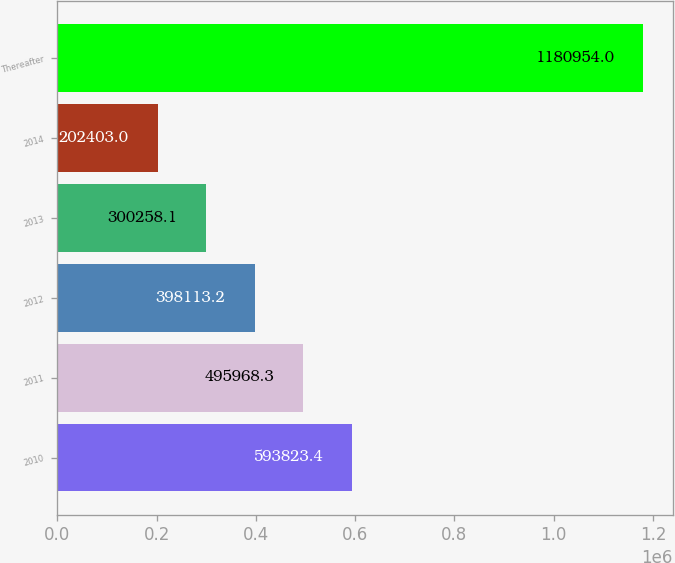Convert chart. <chart><loc_0><loc_0><loc_500><loc_500><bar_chart><fcel>2010<fcel>2011<fcel>2012<fcel>2013<fcel>2014<fcel>Thereafter<nl><fcel>593823<fcel>495968<fcel>398113<fcel>300258<fcel>202403<fcel>1.18095e+06<nl></chart> 